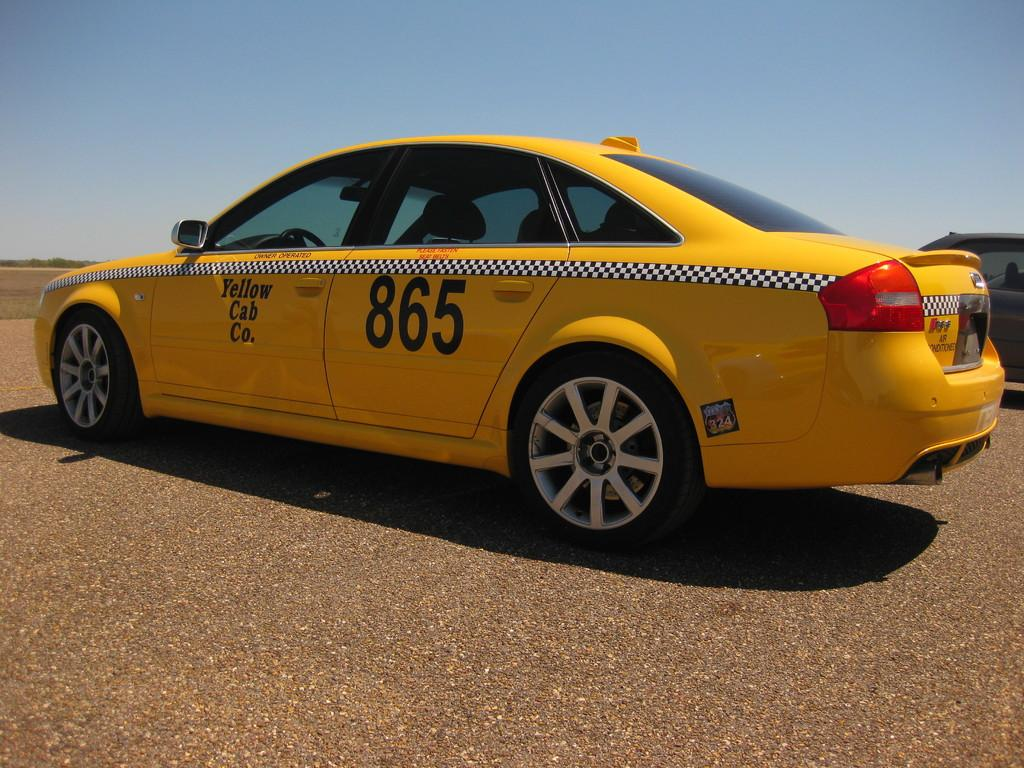Provide a one-sentence caption for the provided image. A yellow cab with the number 865 written on one door. 